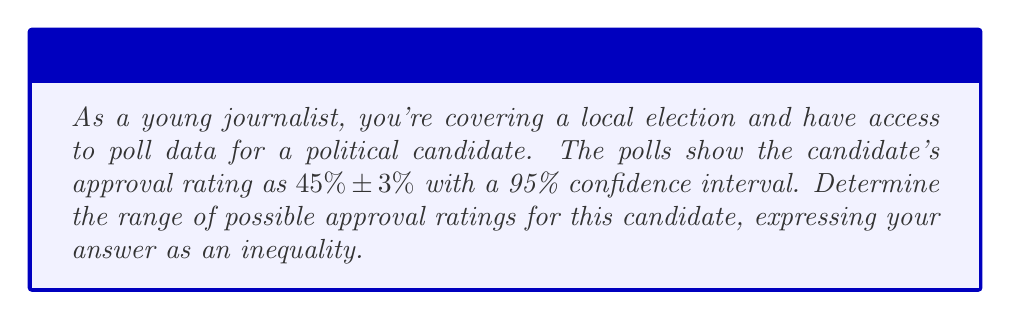Provide a solution to this math problem. To solve this problem, we need to understand the concept of confidence intervals in polling data:

1) The poll result is given as $45\% \pm 3\%$ with a 95% confidence interval.

2) This means that the true approval rating is likely to fall within 3 percentage points above or below 45%.

3) To express this as a range, we need to:
   a) Subtract 3 from 45 to get the lower bound
   b) Add 3 to 45 to get the upper bound

4) Lower bound: $45\% - 3\% = 42\%$
   Upper bound: $45\% + 3\% = 48\%$

5) To express this as an inequality, we use the following notation:
   $42\% \leq x \leq 48\%$

   Where $x$ represents the true approval rating.

6) To convert percentages to decimals, we divide by 100:
   $0.42 \leq x \leq 0.48$

This inequality represents the range of possible approval ratings for the candidate based on the given poll data.
Answer: $0.42 \leq x \leq 0.48$, where $x$ is the true approval rating. 